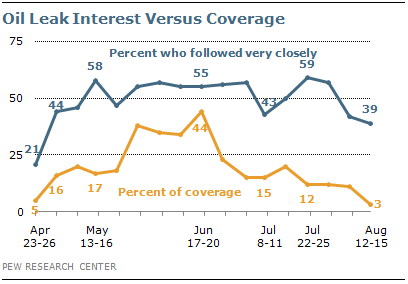Point out several critical features in this image. The peak value of the orange graph is 44. 